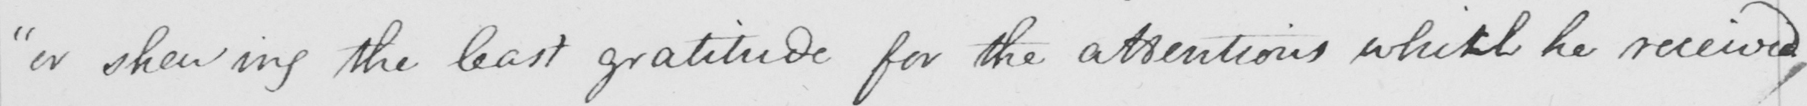What does this handwritten line say? " or shewing the least gratitude for the attentions which he received , 